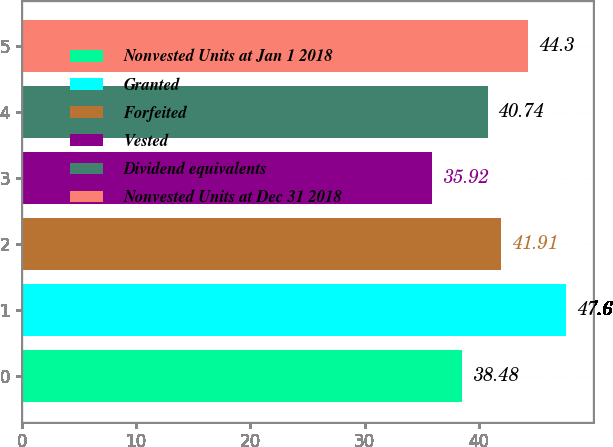<chart> <loc_0><loc_0><loc_500><loc_500><bar_chart><fcel>Nonvested Units at Jan 1 2018<fcel>Granted<fcel>Forfeited<fcel>Vested<fcel>Dividend equivalents<fcel>Nonvested Units at Dec 31 2018<nl><fcel>38.48<fcel>47.6<fcel>41.91<fcel>35.92<fcel>40.74<fcel>44.3<nl></chart> 